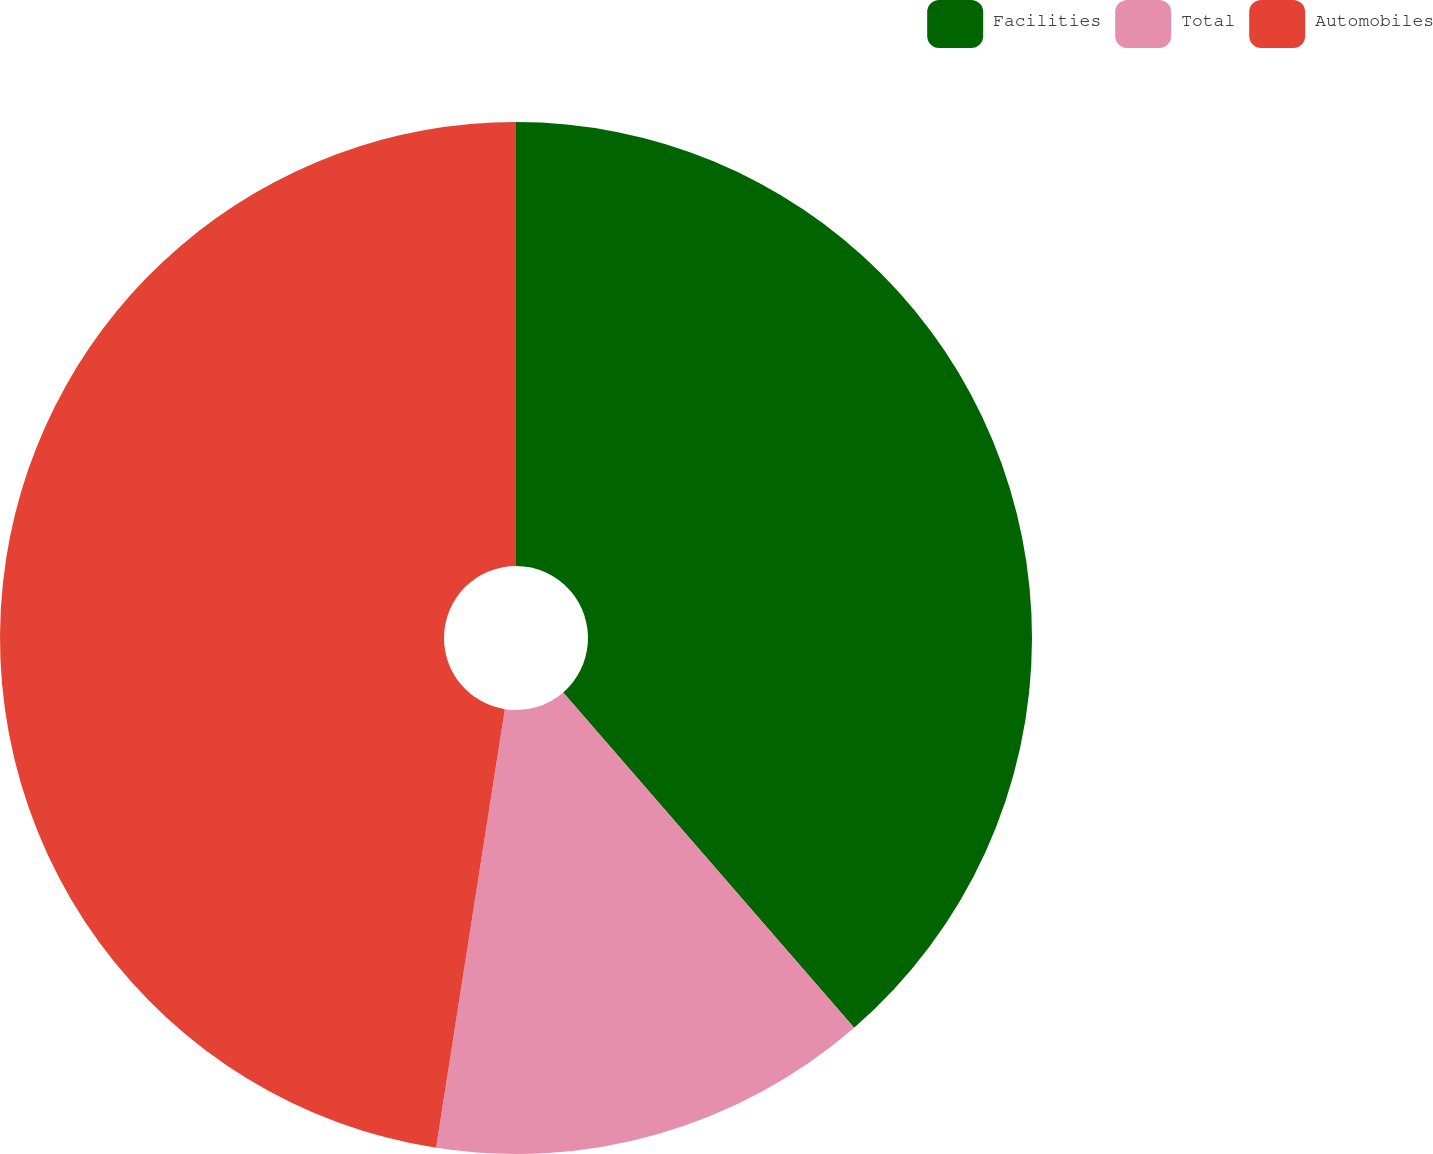<chart> <loc_0><loc_0><loc_500><loc_500><pie_chart><fcel>Facilities<fcel>Total<fcel>Automobiles<nl><fcel>38.63%<fcel>13.85%<fcel>47.53%<nl></chart> 